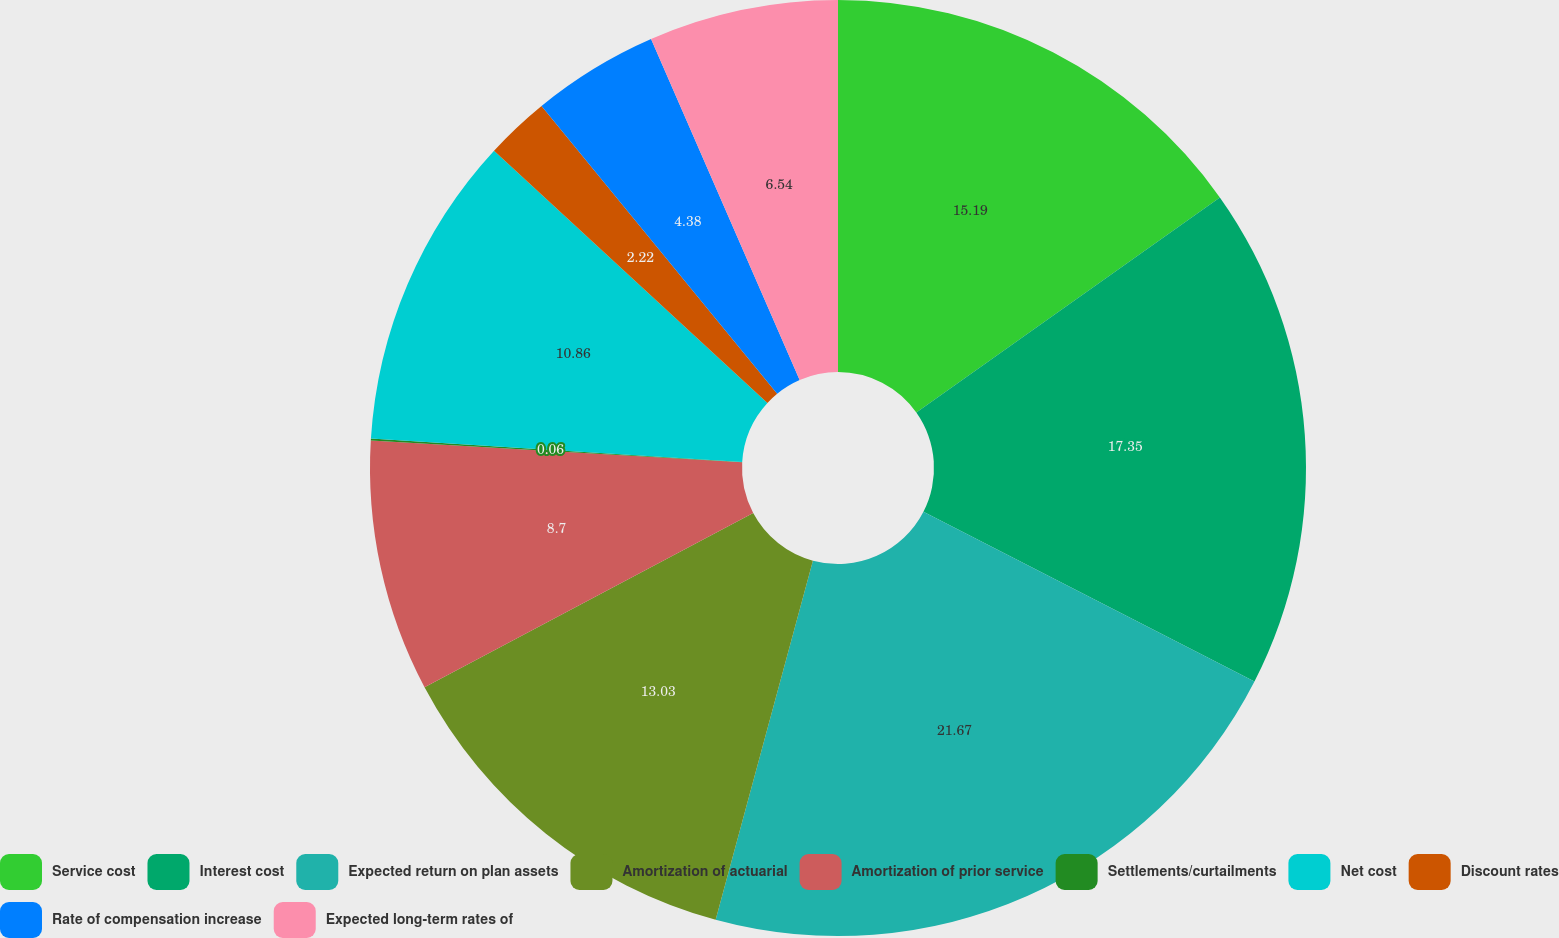<chart> <loc_0><loc_0><loc_500><loc_500><pie_chart><fcel>Service cost<fcel>Interest cost<fcel>Expected return on plan assets<fcel>Amortization of actuarial<fcel>Amortization of prior service<fcel>Settlements/curtailments<fcel>Net cost<fcel>Discount rates<fcel>Rate of compensation increase<fcel>Expected long-term rates of<nl><fcel>15.19%<fcel>17.35%<fcel>21.67%<fcel>13.03%<fcel>8.7%<fcel>0.06%<fcel>10.86%<fcel>2.22%<fcel>4.38%<fcel>6.54%<nl></chart> 